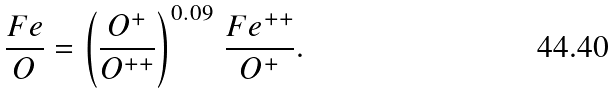Convert formula to latex. <formula><loc_0><loc_0><loc_500><loc_500>\frac { F e } { O } = \left ( \frac { O ^ { + } } { O ^ { + + } } \right ) ^ { 0 . 0 9 } \, \frac { F e ^ { + + } } { O ^ { + } } .</formula> 